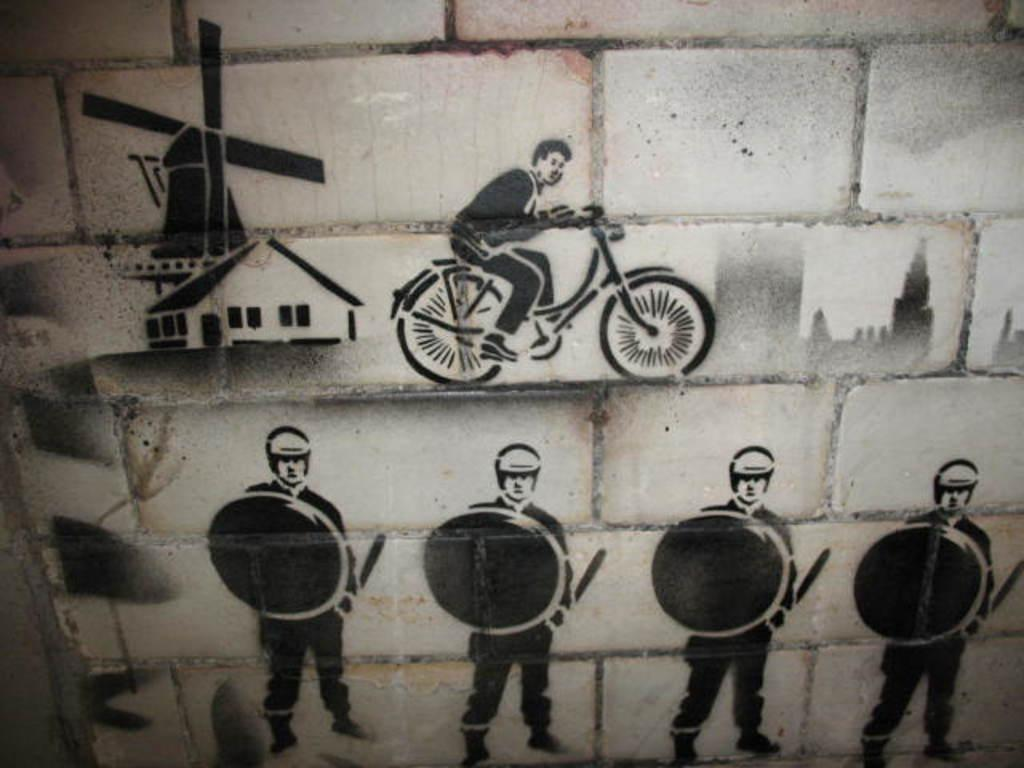What is present on the wall in the image? There is a wall in the image with sketches of a house, people, and a person with a vehicle. Can you describe the sketches of the house? The sketches of the house are on the wall. What other types of sketches are on the wall? There are also sketches of people on the wall. What is the subject of the sketch involving a person and a vehicle? The sketch features a person with a vehicle. How many pens are used to create the sketches on the wall? There is no information about the number of pens used to create the sketches on the wall, as the focus is on the subjects and content of the sketches. 